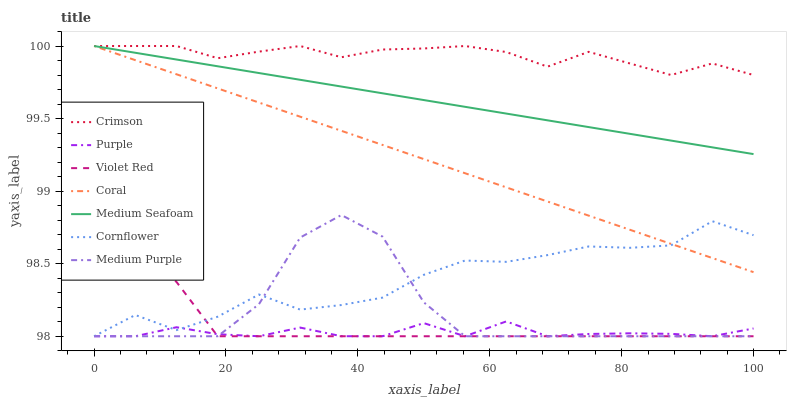Does Purple have the minimum area under the curve?
Answer yes or no. Yes. Does Crimson have the maximum area under the curve?
Answer yes or no. Yes. Does Violet Red have the minimum area under the curve?
Answer yes or no. No. Does Violet Red have the maximum area under the curve?
Answer yes or no. No. Is Coral the smoothest?
Answer yes or no. Yes. Is Medium Purple the roughest?
Answer yes or no. Yes. Is Violet Red the smoothest?
Answer yes or no. No. Is Violet Red the roughest?
Answer yes or no. No. Does Cornflower have the lowest value?
Answer yes or no. Yes. Does Coral have the lowest value?
Answer yes or no. No. Does Medium Seafoam have the highest value?
Answer yes or no. Yes. Does Violet Red have the highest value?
Answer yes or no. No. Is Medium Purple less than Coral?
Answer yes or no. Yes. Is Medium Seafoam greater than Purple?
Answer yes or no. Yes. Does Purple intersect Cornflower?
Answer yes or no. Yes. Is Purple less than Cornflower?
Answer yes or no. No. Is Purple greater than Cornflower?
Answer yes or no. No. Does Medium Purple intersect Coral?
Answer yes or no. No. 